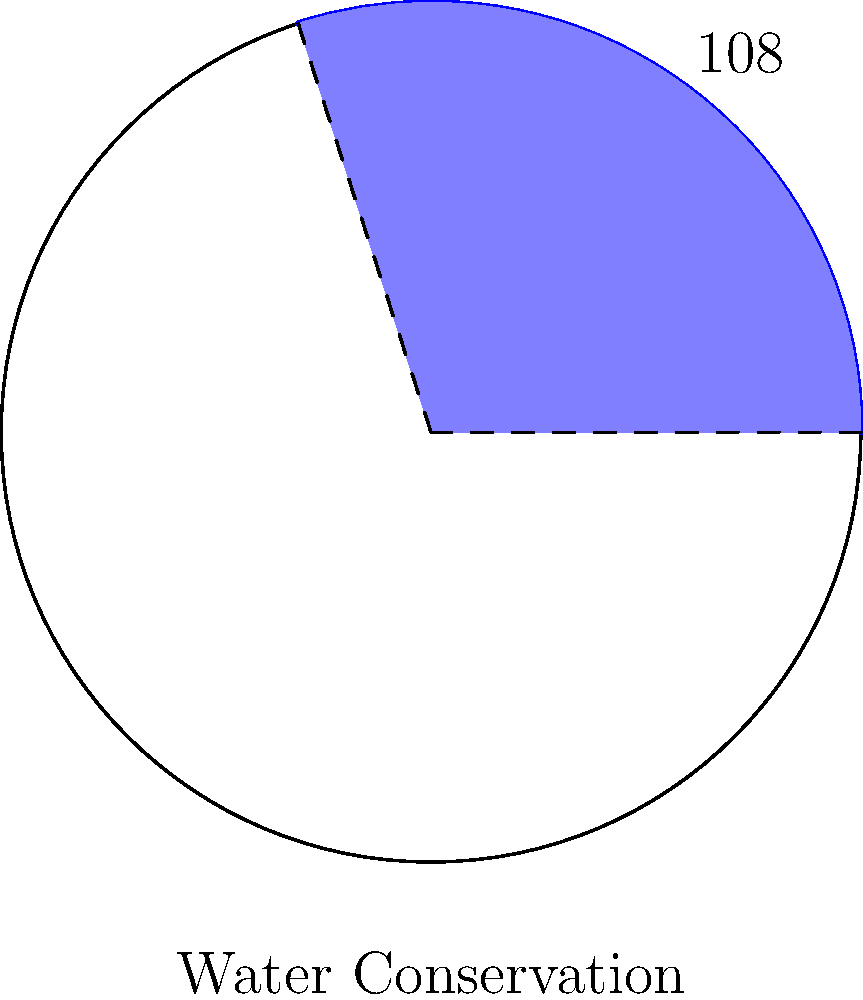In a circular diagram representing various environmental initiatives in your small rural town, the sector for water conservation takes up 108° of the circle. If the circle has a radius of 15 meters, what is the area of the sector representing water conservation? Round your answer to the nearest square meter. To find the area of a sector, we need to follow these steps:

1) Recall the formula for the area of a sector:
   $$A = \frac{\theta}{360°} \cdot \pi r^2$$
   where $\theta$ is the central angle in degrees, and $r$ is the radius.

2) We're given:
   $\theta = 108°$
   $r = 15$ meters

3) Let's substitute these values into our formula:
   $$A = \frac{108°}{360°} \cdot \pi (15\text{ m})^2$$

4) Simplify:
   $$A = \frac{3}{10} \cdot \pi \cdot 225\text{ m}^2$$

5) Calculate:
   $$A = 67.5\pi\text{ m}^2$$
   $$A \approx 212.06\text{ m}^2$$

6) Rounding to the nearest square meter:
   $$A \approx 212\text{ m}^2$$
Answer: 212 m² 